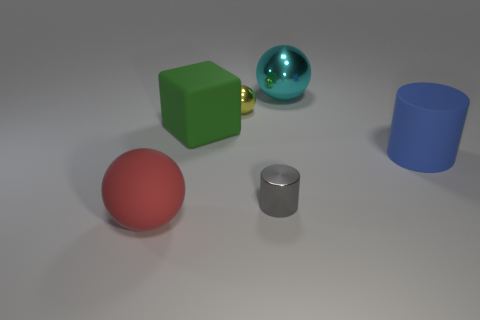What shape is the big thing that is both in front of the yellow ball and behind the big cylinder? cube 